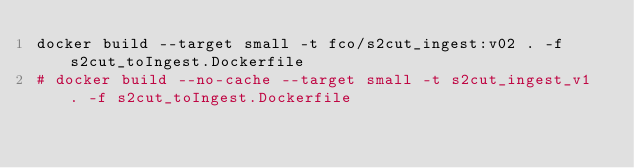Convert code to text. <code><loc_0><loc_0><loc_500><loc_500><_Bash_>docker build --target small -t fco/s2cut_ingest:v02 . -f s2cut_toIngest.Dockerfile
# docker build --no-cache --target small -t s2cut_ingest_v1 . -f s2cut_toIngest.Dockerfile
</code> 